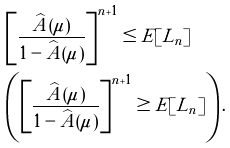Convert formula to latex. <formula><loc_0><loc_0><loc_500><loc_500>& \left [ \frac { \widehat { A } ( \mu ) } { 1 - \widehat { A } ( \mu ) } \right ] ^ { n + 1 } \leq E [ L _ { n } ] \\ & \left ( \left [ \frac { \widehat { A } ( \mu ) } { 1 - \widehat { A } ( \mu ) } \right ] ^ { n + 1 } \geq E [ L _ { n } ] \right ) .</formula> 